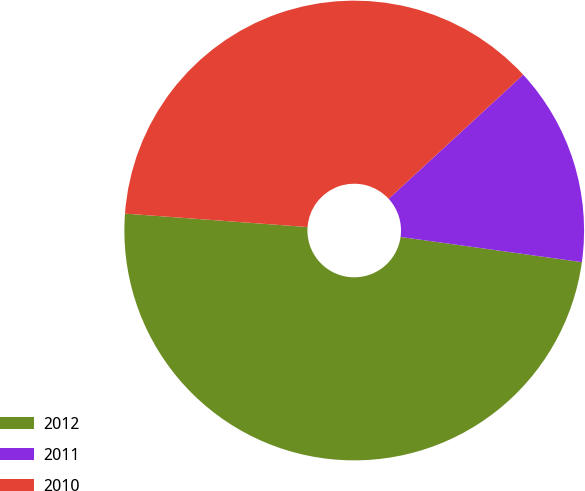<chart> <loc_0><loc_0><loc_500><loc_500><pie_chart><fcel>2012<fcel>2011<fcel>2010<nl><fcel>48.97%<fcel>14.05%<fcel>36.97%<nl></chart> 